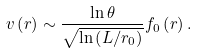<formula> <loc_0><loc_0><loc_500><loc_500>v \left ( r \right ) \sim \frac { \ln \theta } { \sqrt { \ln \left ( L / r _ { 0 } \right ) } } f _ { 0 } \left ( r \right ) .</formula> 